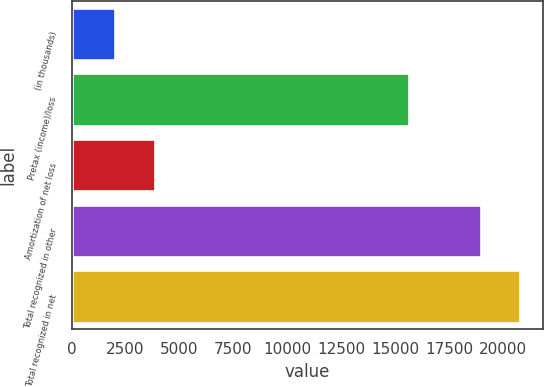<chart> <loc_0><loc_0><loc_500><loc_500><bar_chart><fcel>(in thousands)<fcel>Pretax (income)/loss<fcel>Amortization of net loss<fcel>Total recognized in other<fcel>Total recognized in net<nl><fcel>2017<fcel>15650<fcel>3856.7<fcel>18972<fcel>20811.7<nl></chart> 